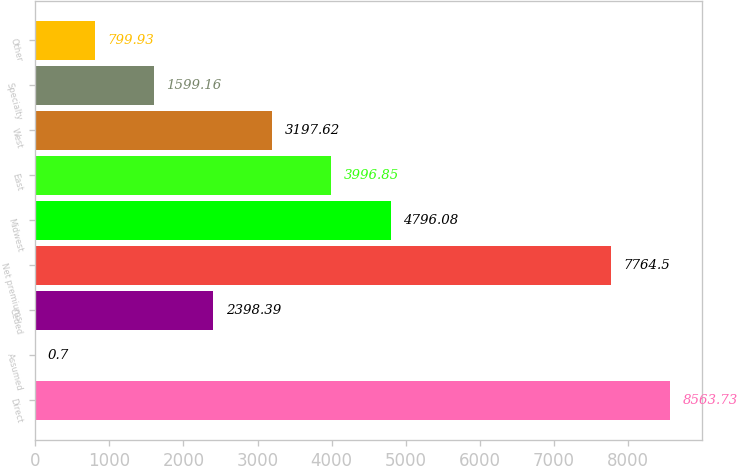<chart> <loc_0><loc_0><loc_500><loc_500><bar_chart><fcel>Direct<fcel>Assumed<fcel>Ceded<fcel>Net premiums<fcel>Midwest<fcel>East<fcel>West<fcel>Specialty<fcel>Other<nl><fcel>8563.73<fcel>0.7<fcel>2398.39<fcel>7764.5<fcel>4796.08<fcel>3996.85<fcel>3197.62<fcel>1599.16<fcel>799.93<nl></chart> 